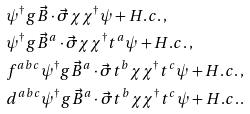<formula> <loc_0><loc_0><loc_500><loc_500>& \psi ^ { \dag } g \vec { B } \cdot \vec { \sigma } \chi \chi ^ { \dag } \psi + H . c . \, , \\ & \psi ^ { \dag } g \vec { B } ^ { a } \cdot \vec { \sigma } \chi \chi ^ { \dag } t ^ { a } \psi + H . c . \, , \\ & f ^ { a b c } \psi ^ { \dag } g \vec { B } ^ { a } \cdot \vec { \sigma } t ^ { b } \chi \chi ^ { \dag } t ^ { c } \psi + H . c . \, , \\ & d ^ { a b c } \psi ^ { \dag } g \vec { B } ^ { a } \cdot \vec { \sigma } t ^ { b } \chi \chi ^ { \dag } t ^ { c } \psi + H . c . \, . \\</formula> 